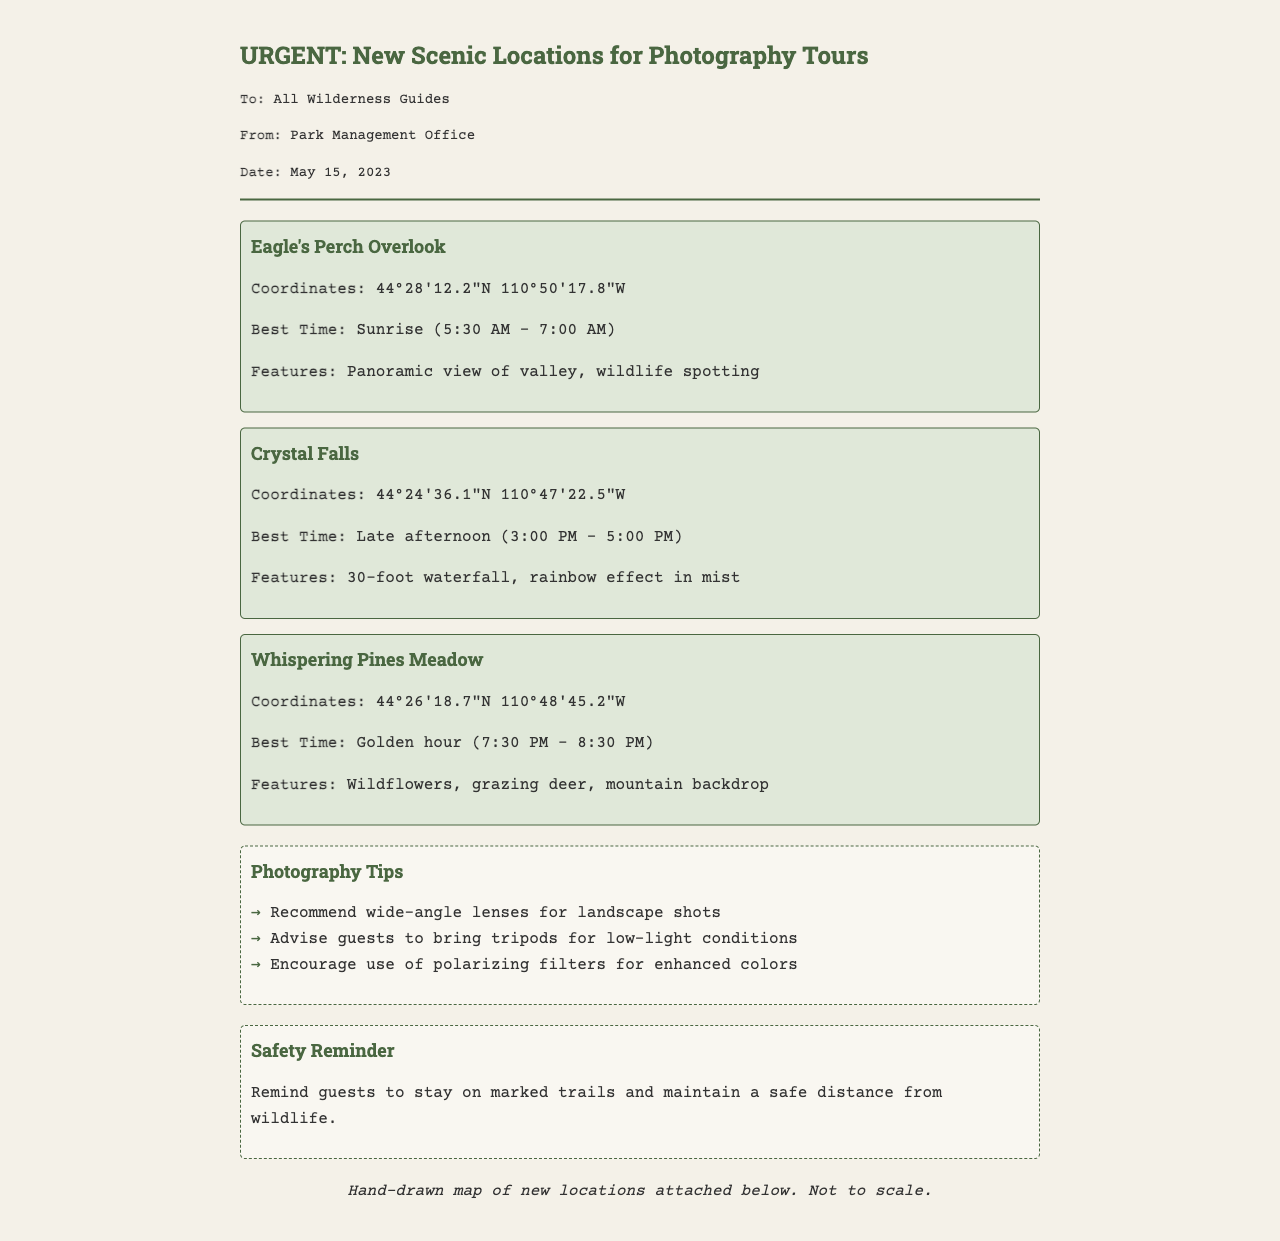What is the title of the document? The title is clearly indicated in the header of the fax.
Answer: URGENT: New Scenic Locations for Photography Tours What are the coordinates for Crystal Falls? The specific coordinates are mentioned directly next to the location's name.
Answer: 44°24'36.1"N 110°47'22.5"W What is the best time for photography at Eagle's Perch Overlook? The document specifies the ideal photography timing for each location.
Answer: Sunrise (5:30 AM - 7:00 AM) Which location features a 30-foot waterfall? The document includes descriptions of features for each location.
Answer: Crystal Falls What type of lens is recommended for landscape shots? Photography tips are explicitly laid out in the tips section of the document.
Answer: Wide-angle lenses What time does the golden hour occur at Whispering Pines Meadow? The best time for photography provided directly in the location's details indicates the timing.
Answer: 7:30 PM - 8:30 PM What reminder is given regarding safety? The document contains a specific reminder related to safety for guests.
Answer: Stay on marked trails Who sent the fax? The sender's information is provided in the header of the fax.
Answer: Park Management Office 